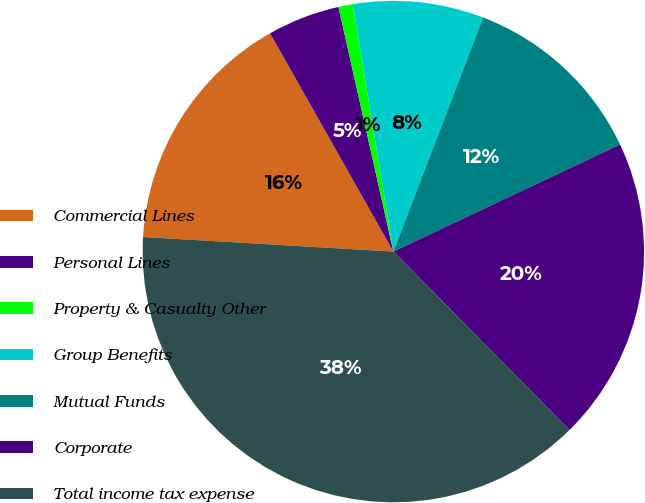Convert chart. <chart><loc_0><loc_0><loc_500><loc_500><pie_chart><fcel>Commercial Lines<fcel>Personal Lines<fcel>Property & Casualty Other<fcel>Group Benefits<fcel>Mutual Funds<fcel>Corporate<fcel>Total income tax expense<nl><fcel>15.89%<fcel>4.67%<fcel>0.93%<fcel>8.41%<fcel>12.15%<fcel>19.63%<fcel>38.32%<nl></chart> 